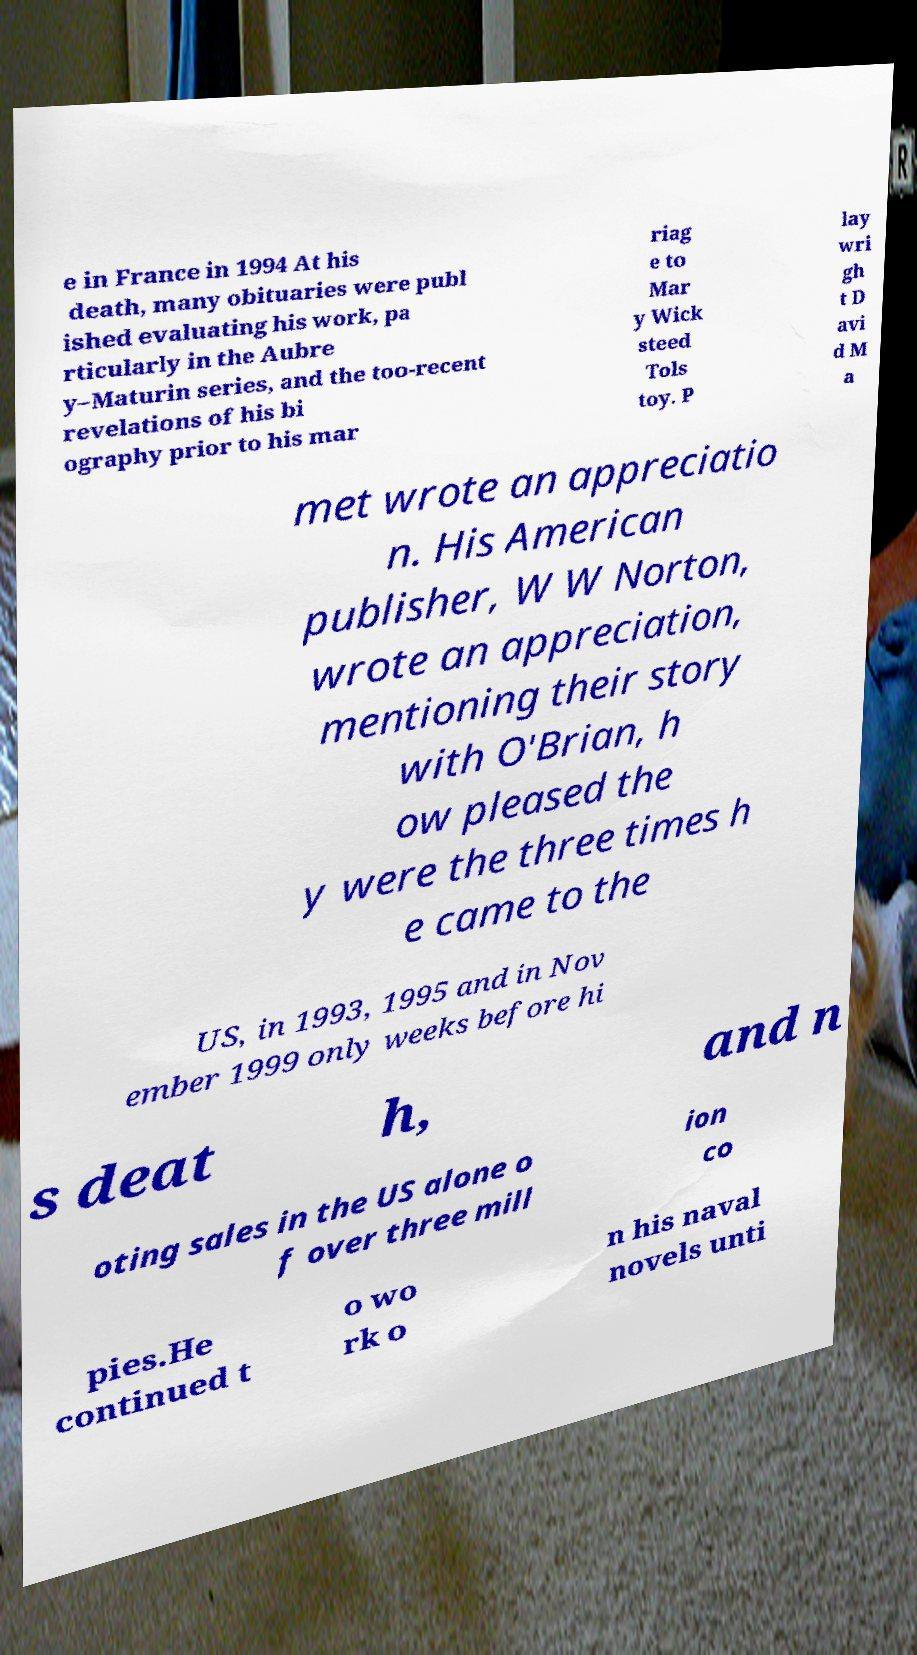Can you accurately transcribe the text from the provided image for me? e in France in 1994 At his death, many obituaries were publ ished evaluating his work, pa rticularly in the Aubre y–Maturin series, and the too-recent revelations of his bi ography prior to his mar riag e to Mar y Wick steed Tols toy. P lay wri gh t D avi d M a met wrote an appreciatio n. His American publisher, W W Norton, wrote an appreciation, mentioning their story with O'Brian, h ow pleased the y were the three times h e came to the US, in 1993, 1995 and in Nov ember 1999 only weeks before hi s deat h, and n oting sales in the US alone o f over three mill ion co pies.He continued t o wo rk o n his naval novels unti 